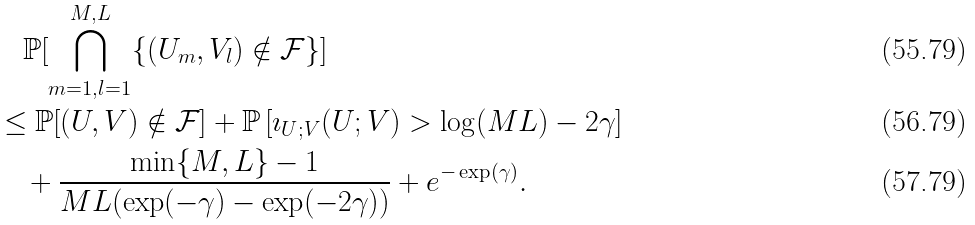<formula> <loc_0><loc_0><loc_500><loc_500>& \quad \mathbb { P } [ \bigcap _ { m = 1 , l = 1 } ^ { M , L } \{ ( U _ { m } , V _ { l } ) \notin \mathcal { F } \} ] \\ & \leq \mathbb { P } [ ( U , V ) \notin \mathcal { F } ] + \mathbb { P } \left [ \imath _ { U ; V } ( U ; V ) > \log ( M L ) - 2 \gamma \right ] \\ & \quad + \frac { \min \{ M , L \} - 1 } { M L ( \exp ( - \gamma ) - \exp ( - 2 \gamma ) ) } + e ^ { - \exp ( \gamma ) } .</formula> 